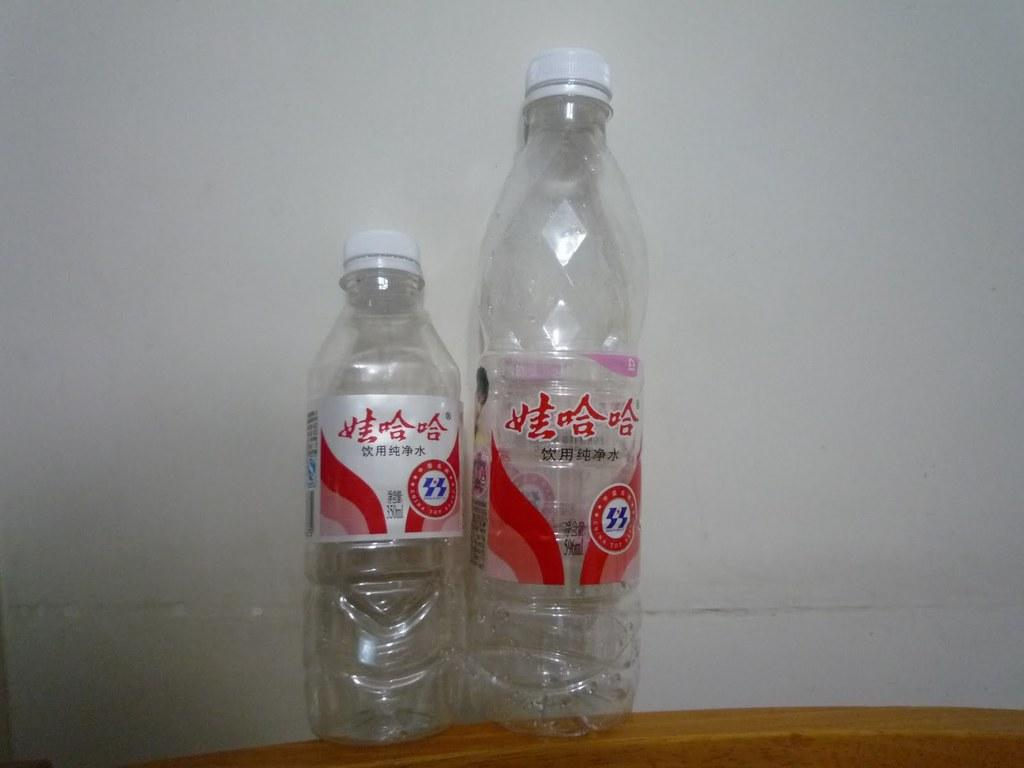How many bottles are present in the image? There are two bottles in the image. Where are the bottles located? The bottles are on a table. What can be seen in the background of the image? There is a wall visible in the background of the image. What type of canvas is being used to connect the bottles in the image? There is no canvas or connection between the bottles in the image; they are simply placed on a table. 